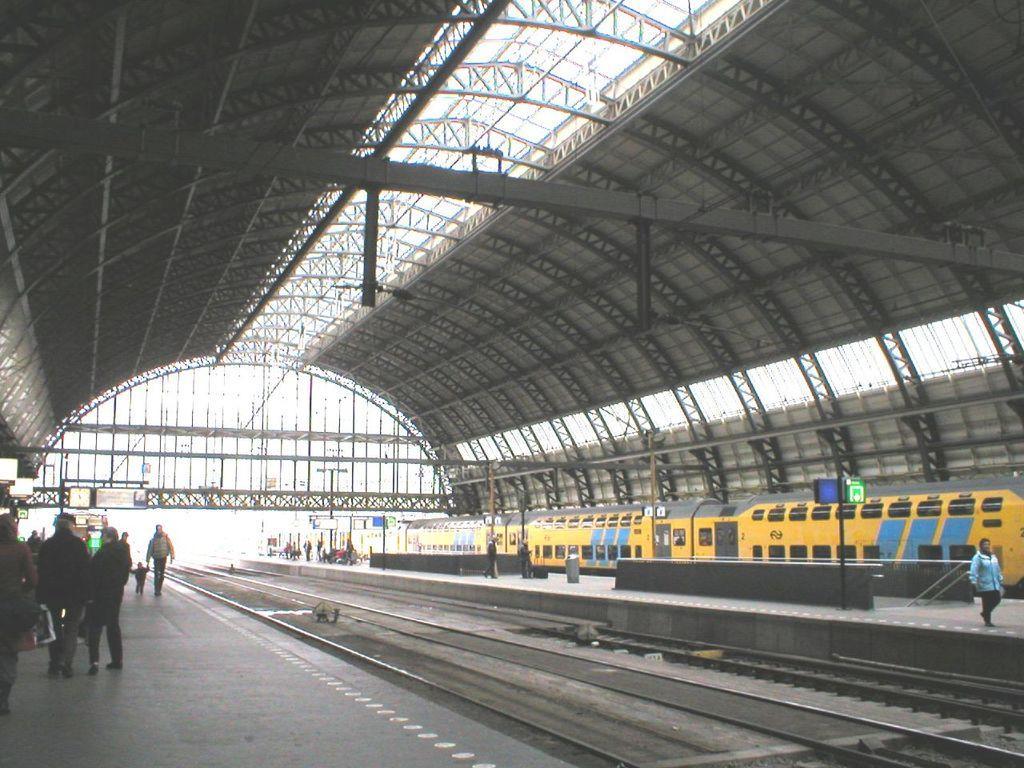How would you summarize this image in a sentence or two? In the image there is a railway station and there is a train on the track, beside the train there are platforms and on the platforms there are passengers and there is a big roof above the railway tracks. 